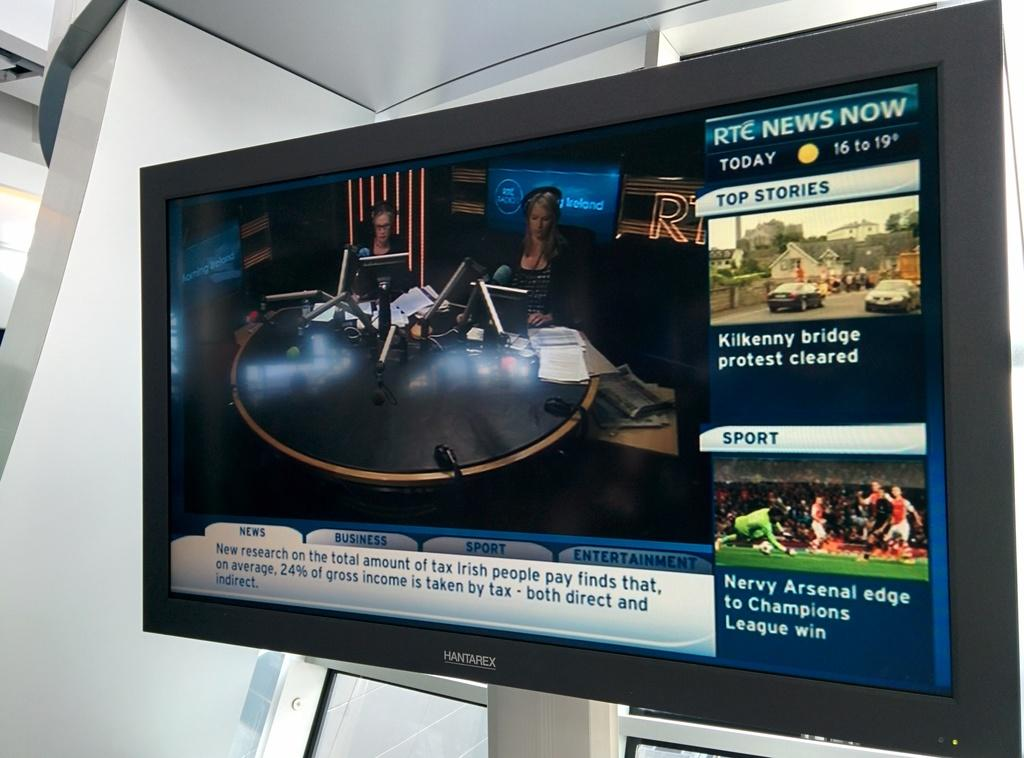<image>
Present a compact description of the photo's key features. A news boradcast on the television with RTC News Now written in the top right 